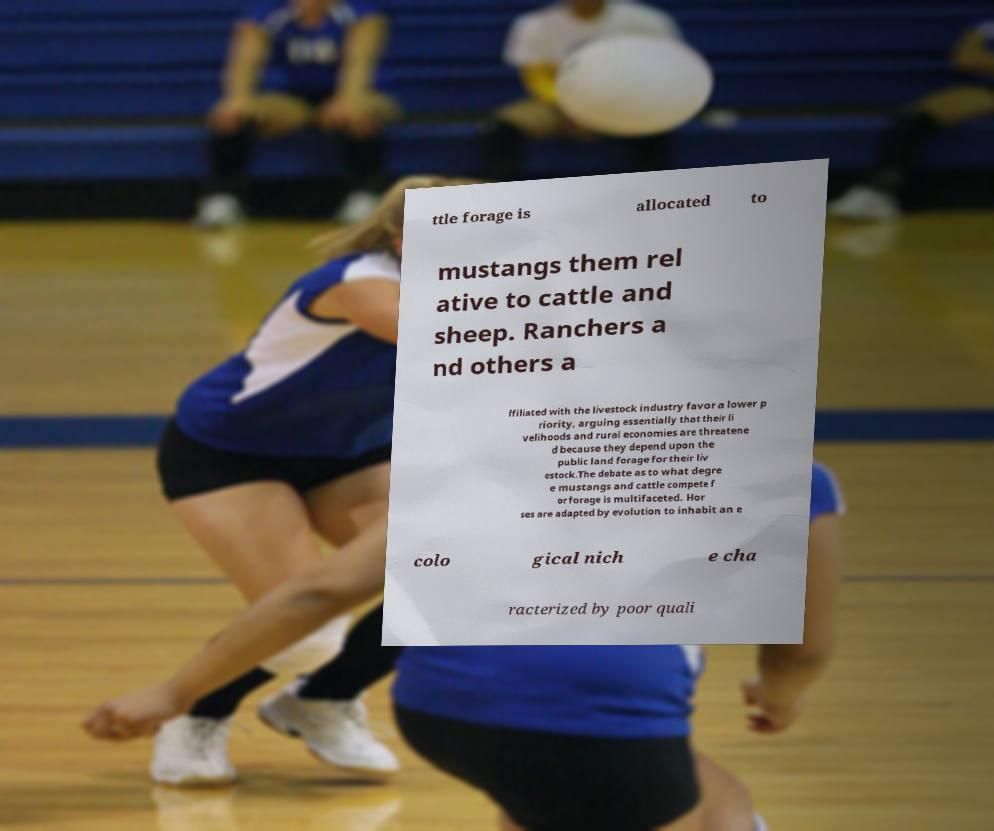For documentation purposes, I need the text within this image transcribed. Could you provide that? ttle forage is allocated to mustangs them rel ative to cattle and sheep. Ranchers a nd others a ffiliated with the livestock industry favor a lower p riority, arguing essentially that their li velihoods and rural economies are threatene d because they depend upon the public land forage for their liv estock.The debate as to what degre e mustangs and cattle compete f or forage is multifaceted. Hor ses are adapted by evolution to inhabit an e colo gical nich e cha racterized by poor quali 